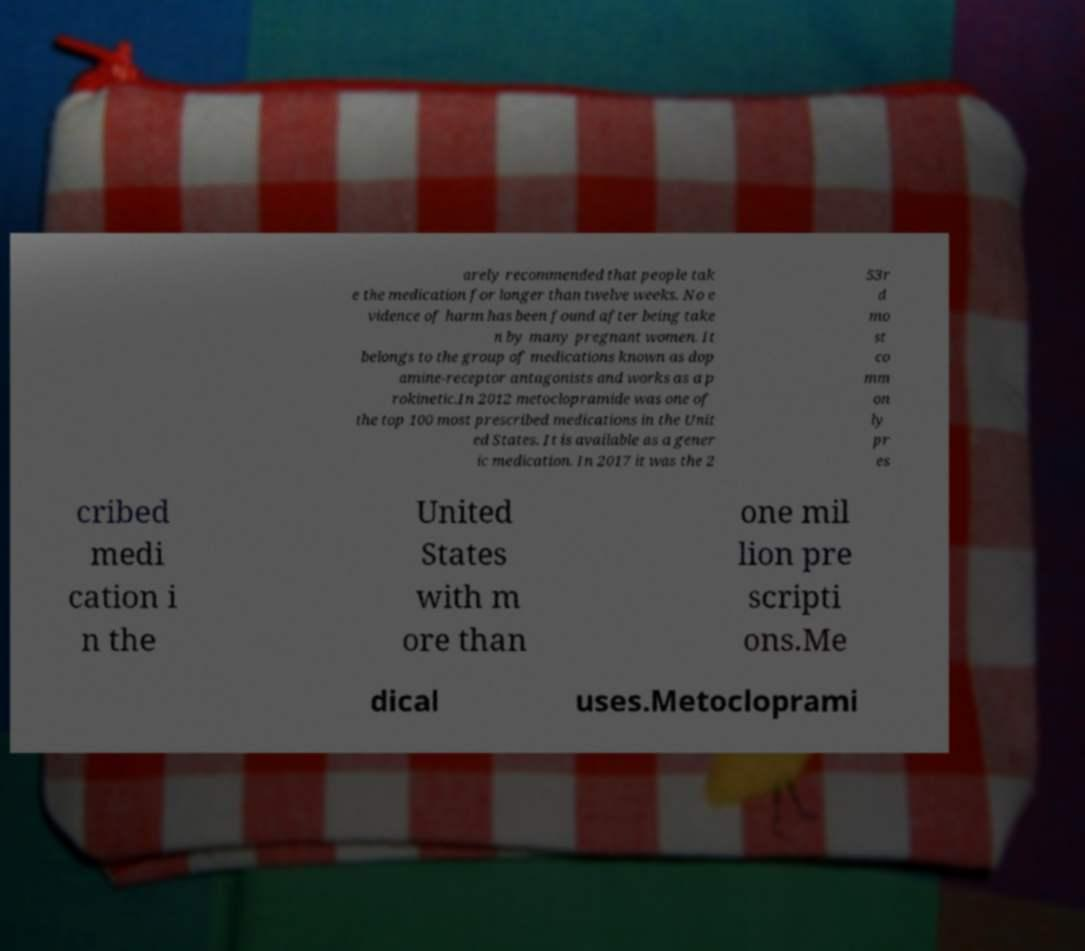For documentation purposes, I need the text within this image transcribed. Could you provide that? arely recommended that people tak e the medication for longer than twelve weeks. No e vidence of harm has been found after being take n by many pregnant women. It belongs to the group of medications known as dop amine-receptor antagonists and works as a p rokinetic.In 2012 metoclopramide was one of the top 100 most prescribed medications in the Unit ed States. It is available as a gener ic medication. In 2017 it was the 2 53r d mo st co mm on ly pr es cribed medi cation i n the United States with m ore than one mil lion pre scripti ons.Me dical uses.Metocloprami 